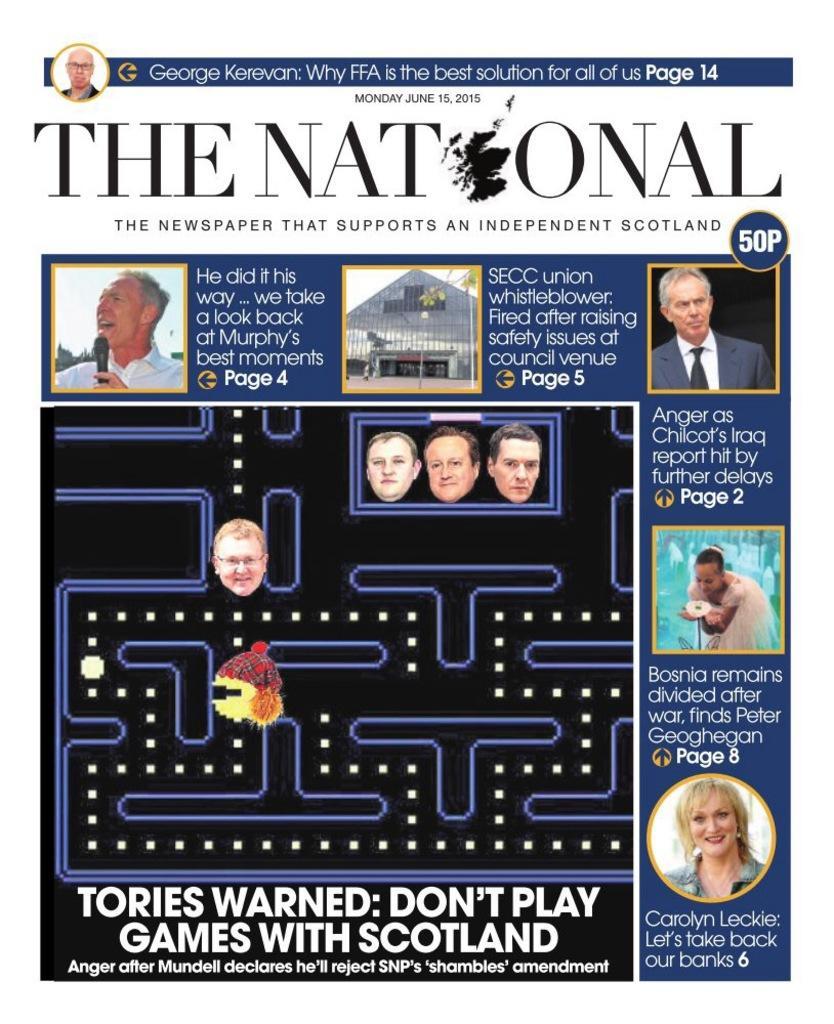Could you give a brief overview of what you see in this image? This is a poster. Here we can see a maze game and there are some texts written on it and there is a heading and we can see few small pics over here. 